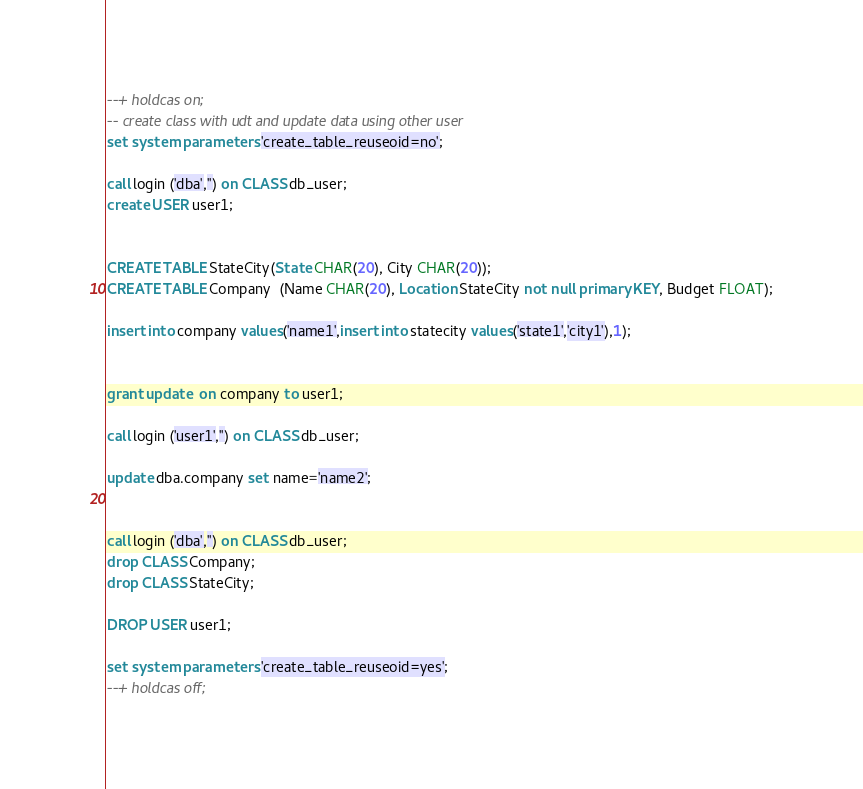<code> <loc_0><loc_0><loc_500><loc_500><_SQL_>--+ holdcas on;
-- create class with udt and update data using other user
set system parameters 'create_table_reuseoid=no';

call login ('dba','') on CLASS db_user;
create USER user1;


CREATE TABLE StateCity(State CHAR(20), City CHAR(20));
CREATE TABLE Company  (Name CHAR(20), Location StateCity not null primary KEY, Budget FLOAT);

insert into company values('name1',insert into statecity values('state1','city1'),1);


grant update  on company to user1;

call login ('user1','') on CLASS db_user;

update dba.company set name='name2';


call login ('dba','') on CLASS db_user;
drop CLASS Company;
drop CLASS StateCity;

DROP USER user1;

set system parameters 'create_table_reuseoid=yes';
--+ holdcas off;
</code> 